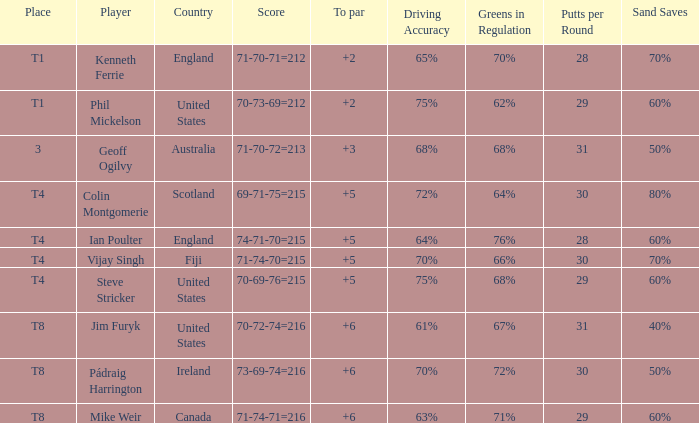What player was place of t1 in To Par and had a score of 70-73-69=212? 2.0. 